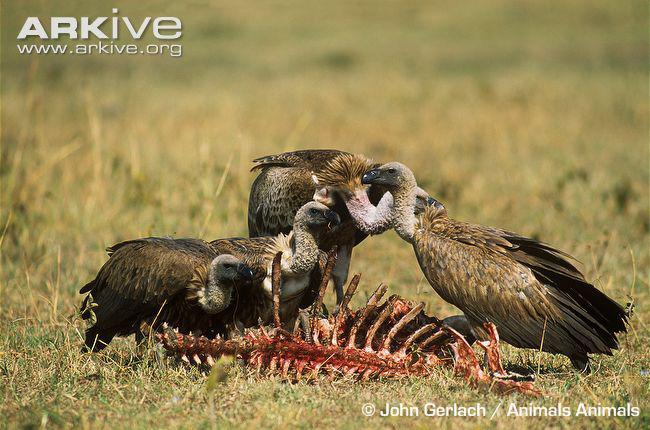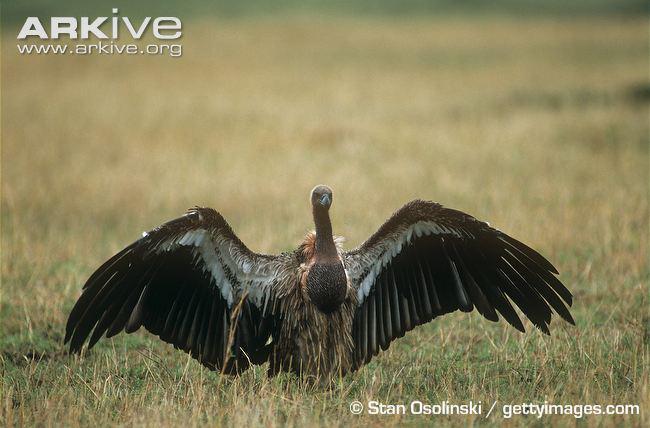The first image is the image on the left, the second image is the image on the right. Given the left and right images, does the statement "birds are feeding off a carcass" hold true? Answer yes or no. Yes. 